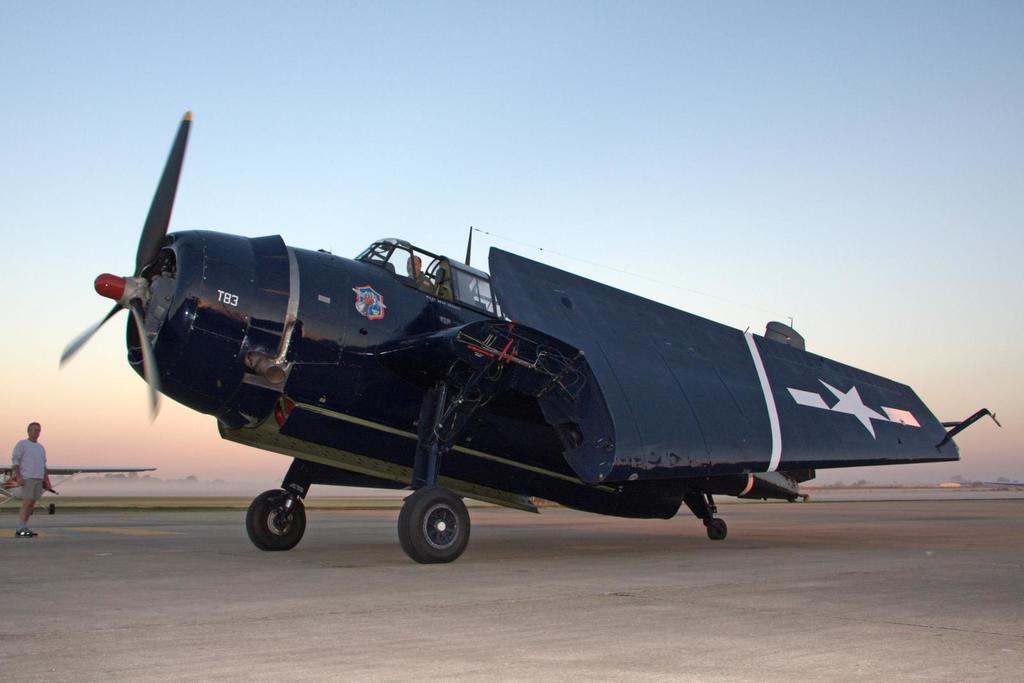What is the number on the nose of the plane?
Provide a succinct answer. T83. 